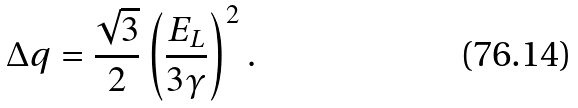<formula> <loc_0><loc_0><loc_500><loc_500>\Delta q = \frac { \sqrt { 3 } } { 2 } \left ( \frac { E _ { L } } { 3 \gamma } \right ) ^ { 2 } .</formula> 